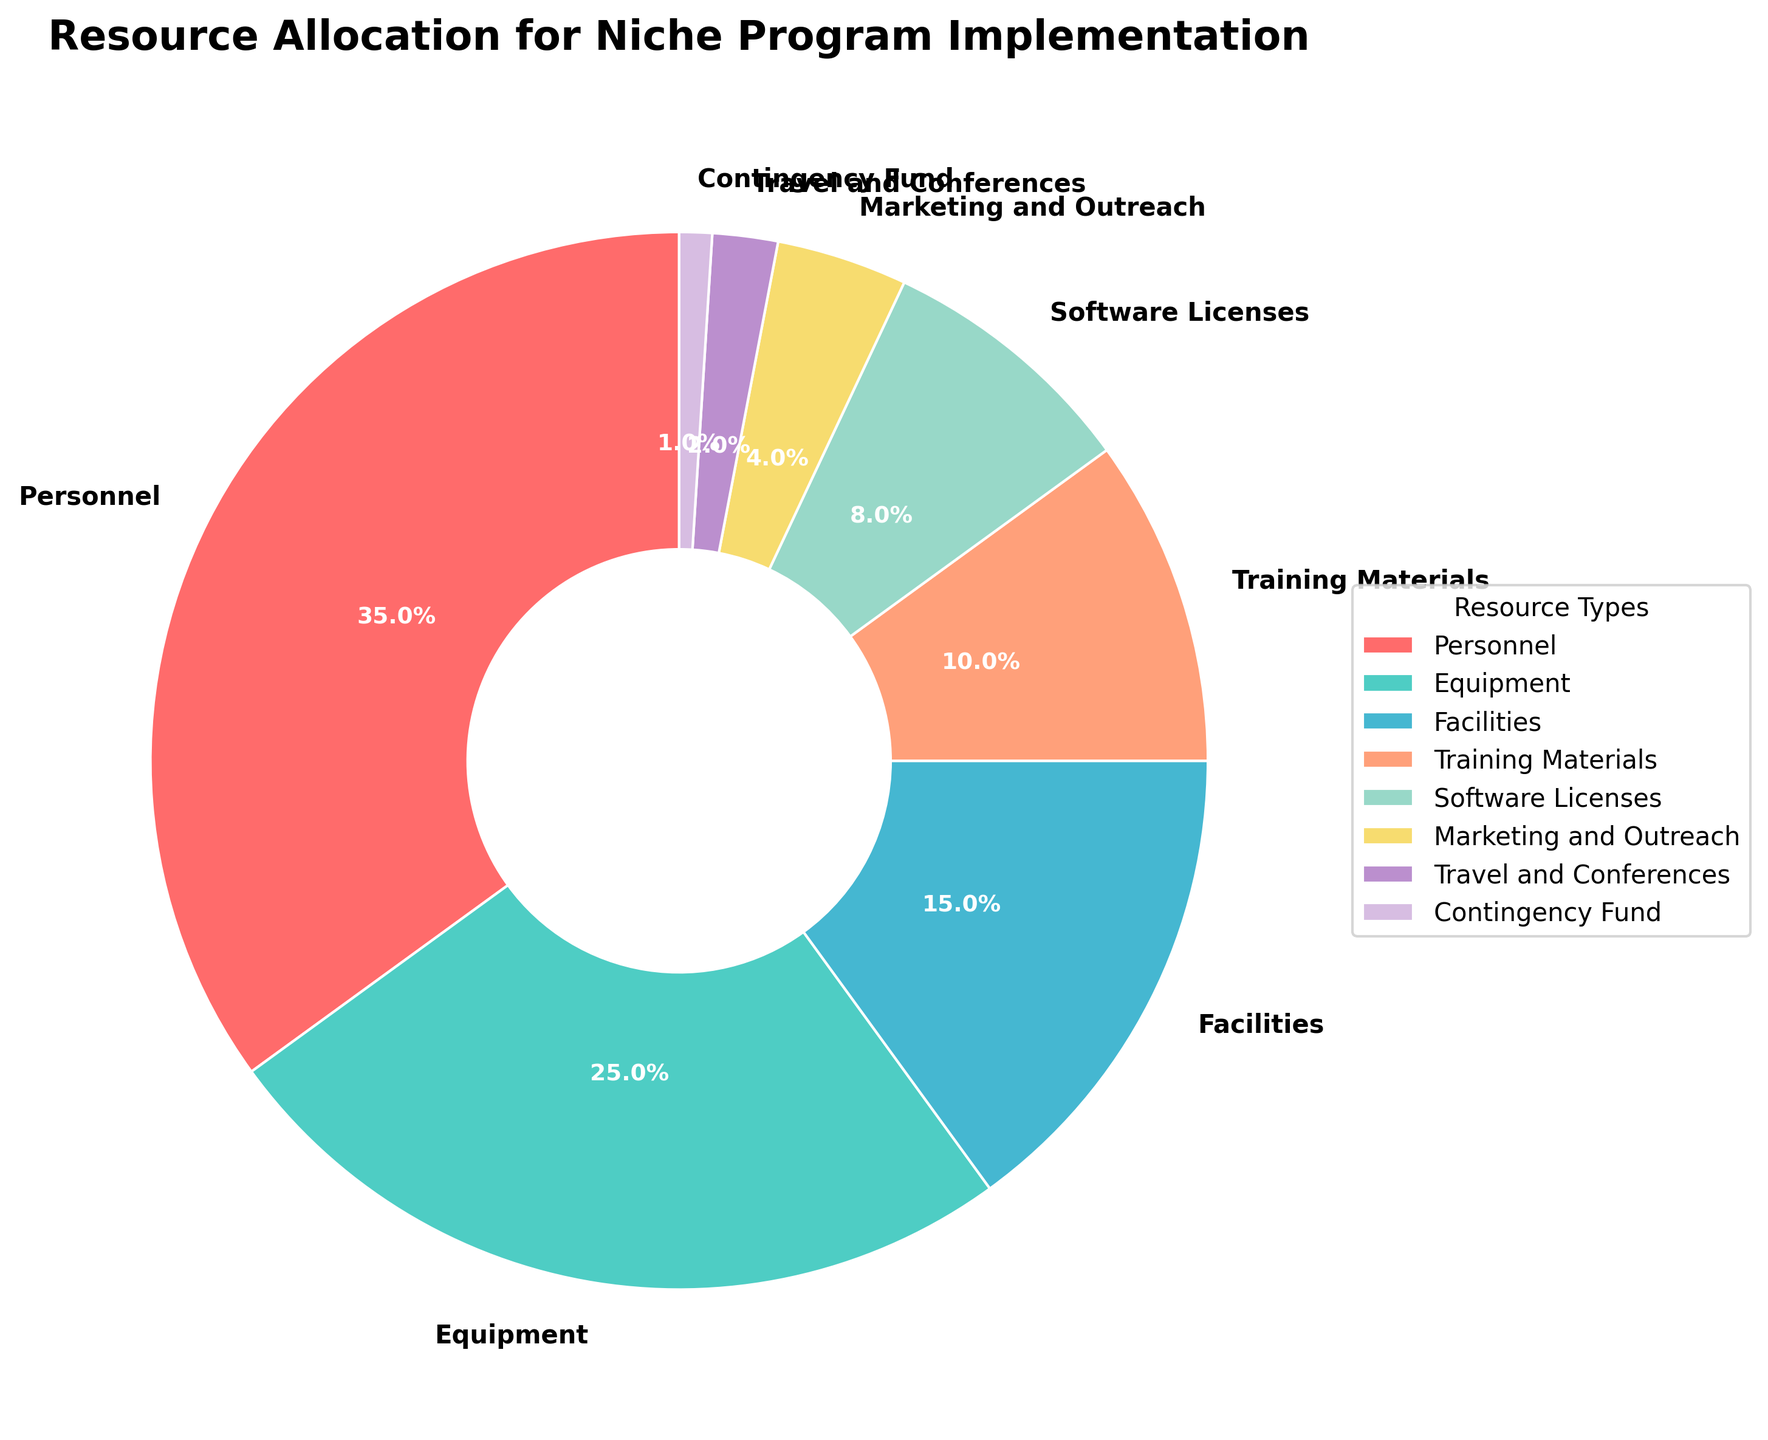What percentage of the resources is allocated to Personnel? From the figure, identify the segment labeled as Personnel and check the percentage displayed next to it.
Answer: 35% Which resource type has the smallest allocation? Locate the smallest wedge in the pie chart and check the label next to it.
Answer: Contingency Fund What is the total percentage allocation for Equipment, Facilities, and Training Materials? Look at the wedges labeled as Equipment, Facilities, and Training Materials, add up their percentages: 25% (Equipment) + 15% (Facilities) + 10% (Training Materials) = 50%
Answer: 50% Is the percentage allocated to Software Licenses greater or lesser than that to Marketing and Outreach? Compare the wedges for Software Licenses and Marketing and Outreach by directly checking their percentages: Software Licenses (8%) and Marketing and Outreach (4%).
Answer: Greater What color represents Equipment in the pie chart? Identify the wedge labeled as Equipment and note its color in the chart.
Answer: Teal Calculate the combined percentage allocation for Marketing and Outreach, and Travel and Conferences. Sum the percentages for Marketing and Outreach (4%) and Travel and Conferences (2%): 4% + 2% = 6%
Answer: 6% Which resource types have a combined percentage allocation greater than 50%? Starting from the highest percentages, keep summing the allocations until the cumulative sum exceeds 50%. The key steps are: Personnel 35% + Equipment 25% = 60%.
Answer: Personnel, Equipment How much more percentage is allocated to Personnel than to Software Licenses? Subtract the percentage for Software Licenses (8%) from the percentage for Personnel (35%): 35% - 8% = 27%
Answer: 27% What is the difference in percentage allocation between Facilities and Travel and Conferences? Subtract the percentage for Travel and Conferences (2%) from the percentage for Facilities (15%): 15% - 2% = 13%
Answer: 13% If we were to increase the allocation for Training Materials by 5%, what would its new percentage be? Add 5% to the current percentage for Training Materials: 10% + 5% = 15%
Answer: 15% 